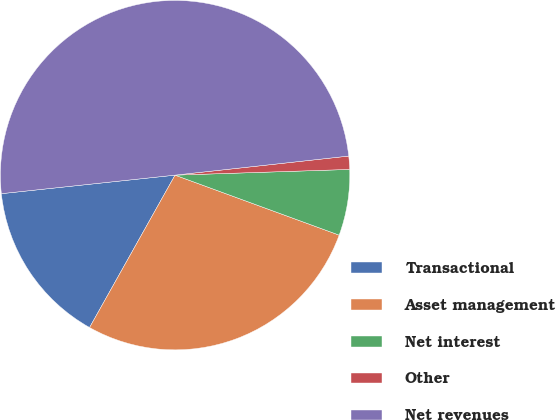<chart> <loc_0><loc_0><loc_500><loc_500><pie_chart><fcel>Transactional<fcel>Asset management<fcel>Net interest<fcel>Other<fcel>Net revenues<nl><fcel>15.17%<fcel>27.56%<fcel>6.1%<fcel>1.22%<fcel>49.95%<nl></chart> 